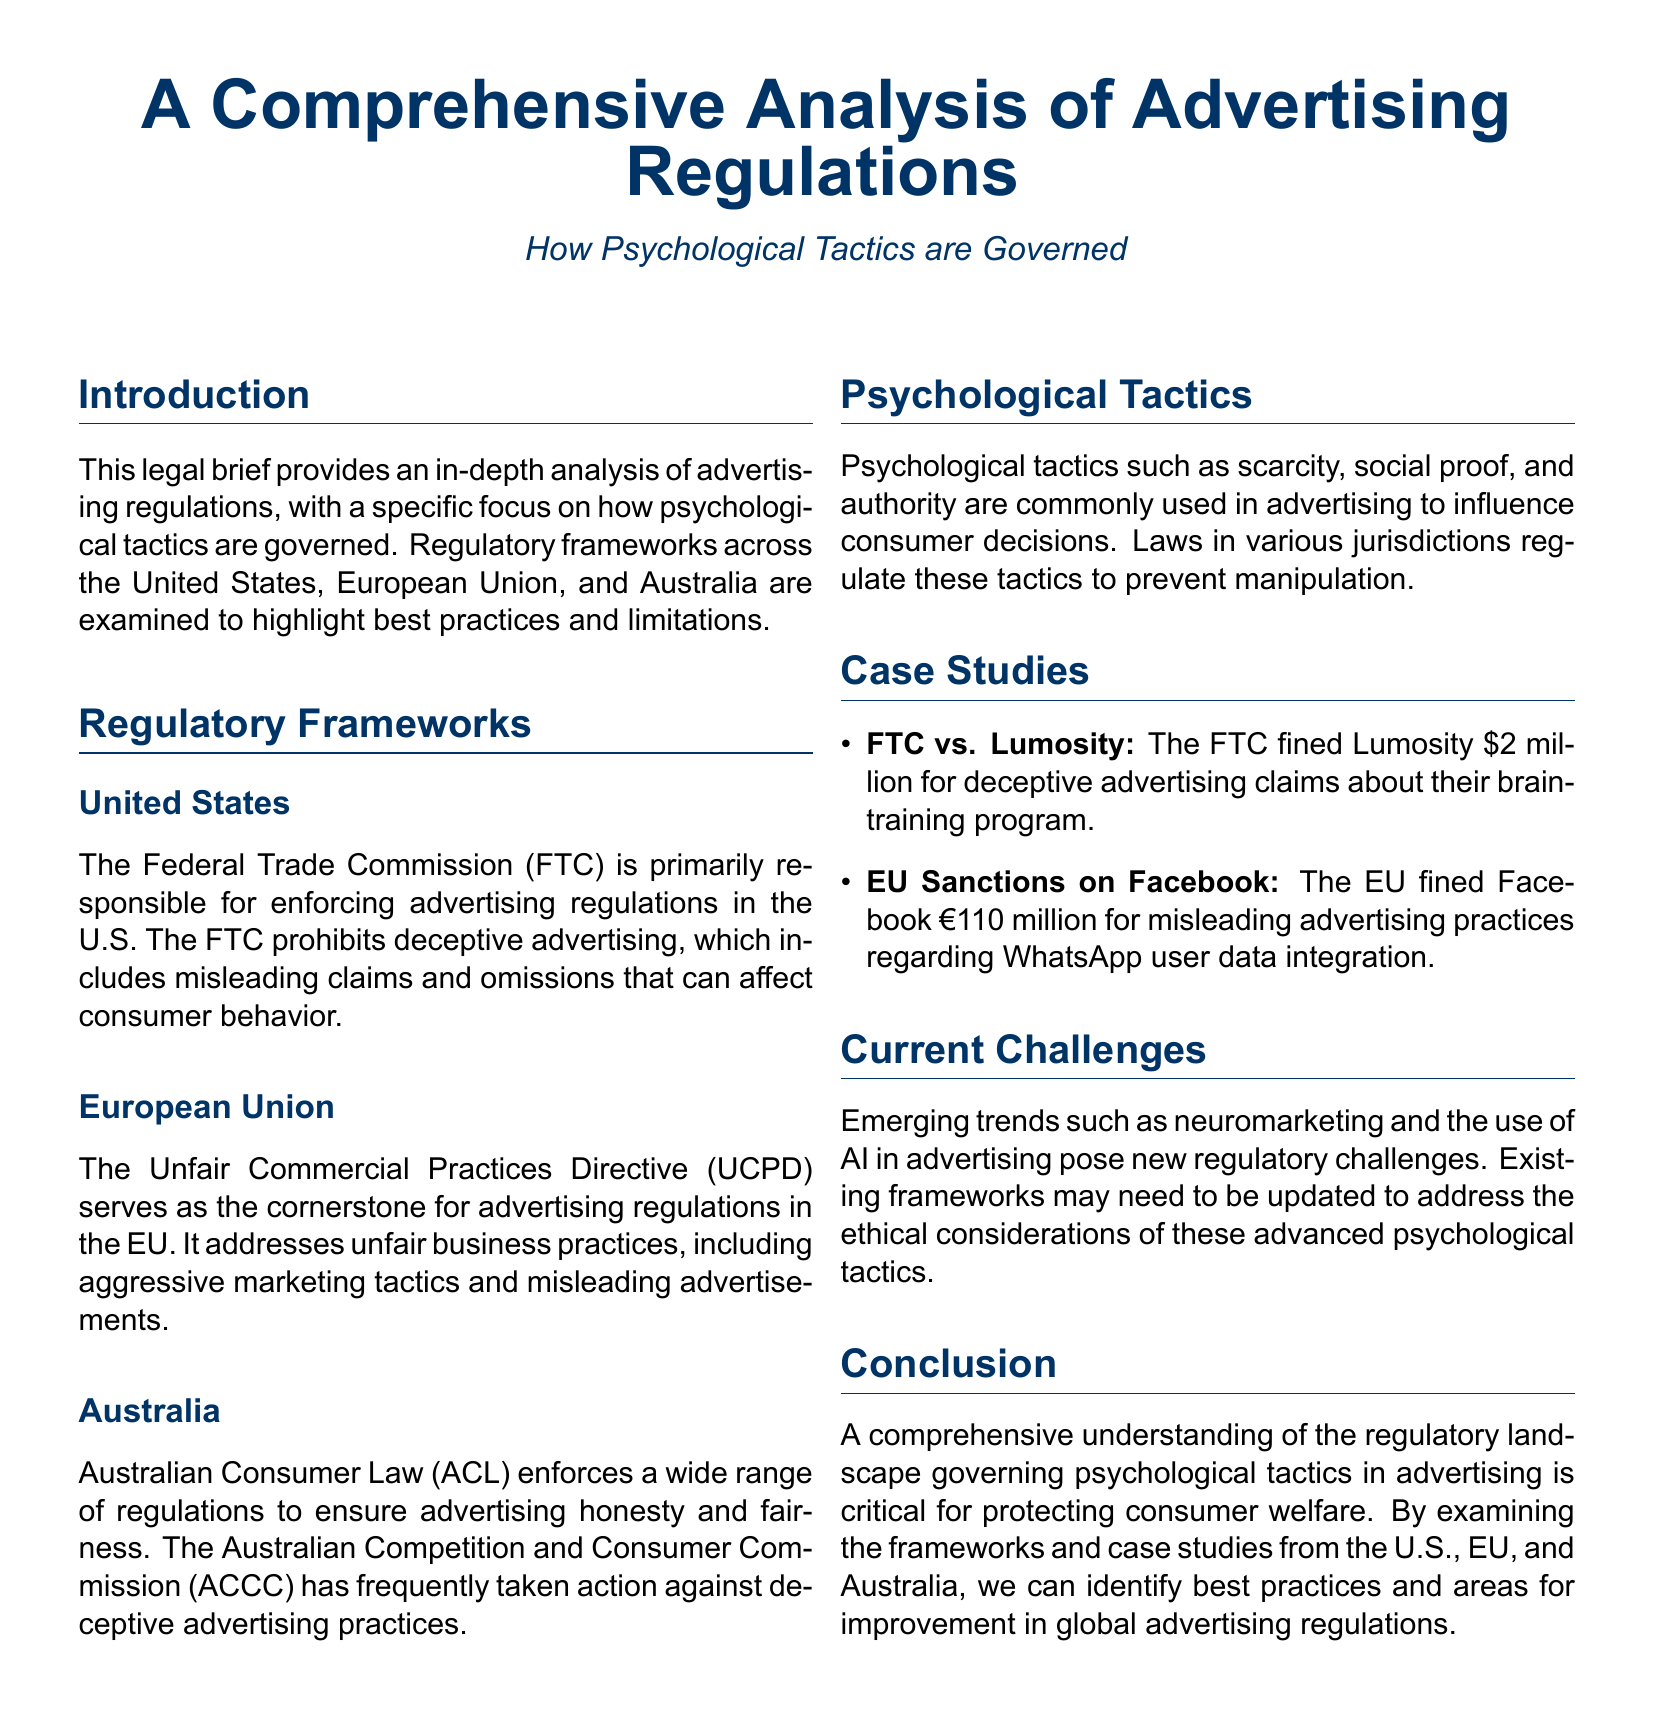What is the primary organization responsible for advertising regulation in the U.S.? The document states that the Federal Trade Commission (FTC) is primarily responsible for enforcing advertising regulations in the U.S.
Answer: Federal Trade Commission (FTC) What directive governs advertising regulations in the European Union? The Unfair Commercial Practices Directive (UCPD) is mentioned as the cornerstone for advertising regulations in the EU.
Answer: Unfair Commercial Practices Directive (UCPD) How much was Lumosity fined by the FTC? The document specifies that Lumosity was fined $2 million for deceptive advertising claims.
Answer: $2 million What does the Australian Consumer Law (ACL) aim to ensure? According to the document, the ACL enforces regulations to ensure advertising honesty and fairness.
Answer: Advertising honesty and fairness What psychological tactic is commonly used in advertising? The document refers to psychological tactics such as scarcity, social proof, and authority being used in advertising.
Answer: Scarcity, social proof, and authority What is a current challenge mentioned in the document regarding advertising regulations? The document discusses emerging trends like neuromarketing and the use of AI posing new regulatory challenges.
Answer: Neuromarketing and AI What is the purpose of the legal brief? The purpose of the brief is to provide an in-depth analysis of advertising regulations and how psychological tactics are governed.
Answer: Analysis of advertising regulations and psychological tactics What are the case studies included in the document? The case studies provide examples like FTC vs. Lumosity and EU sanctions on Facebook regarding advertising practices.
Answer: FTC vs. Lumosity and EU sanctions on Facebook Which country's commission has taken action against deceptive advertising practices? The document mentions that the Australian Competition and Consumer Commission (ACCC) has frequently taken action against deceptive advertising practices.
Answer: Australian Competition and Consumer Commission (ACCC) What is critical for protecting consumer welfare according to the conclusion? The conclusion emphasizes that a comprehensive understanding of the regulatory landscape is critical for protecting consumer welfare.
Answer: Comprehensive understanding of the regulatory landscape 